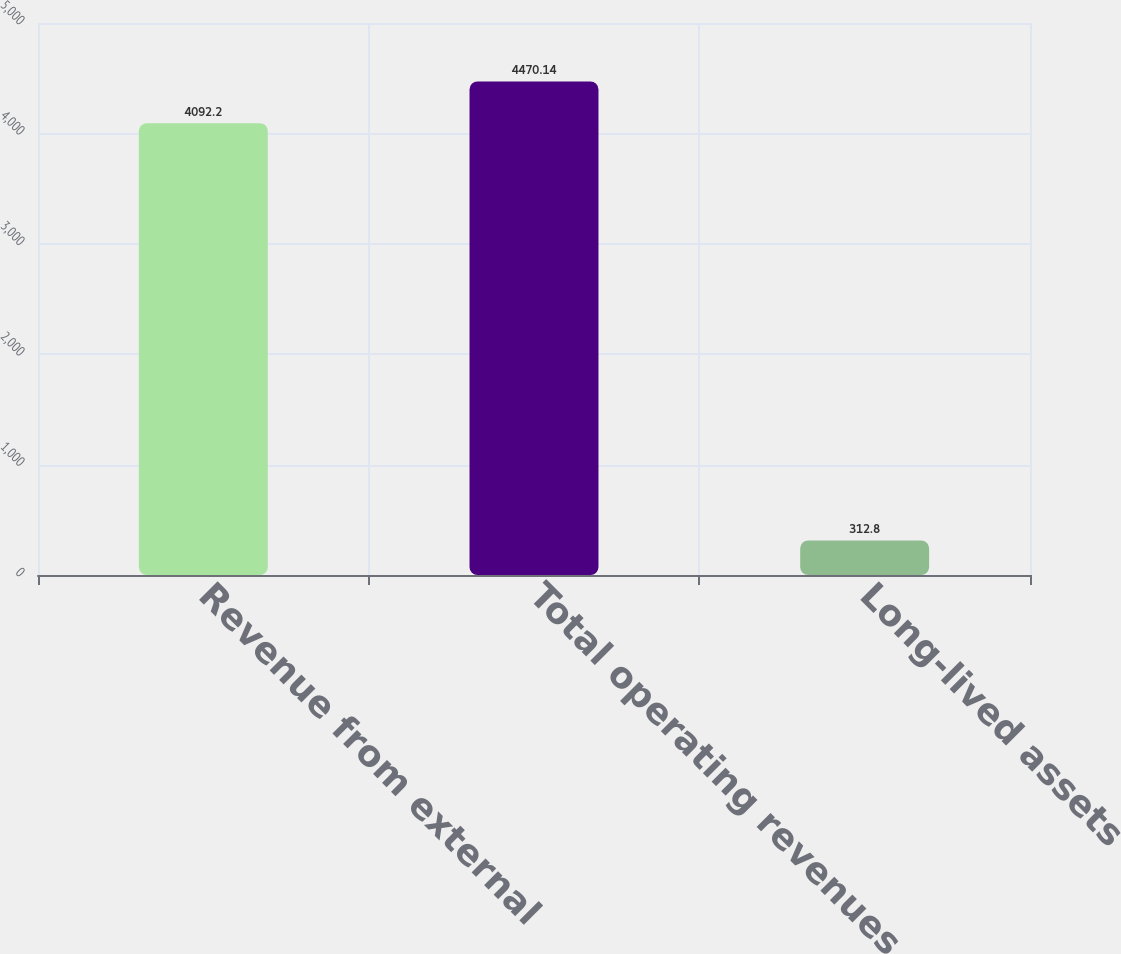Convert chart to OTSL. <chart><loc_0><loc_0><loc_500><loc_500><bar_chart><fcel>Revenue from external<fcel>Total operating revenues<fcel>Long-lived assets<nl><fcel>4092.2<fcel>4470.14<fcel>312.8<nl></chart> 